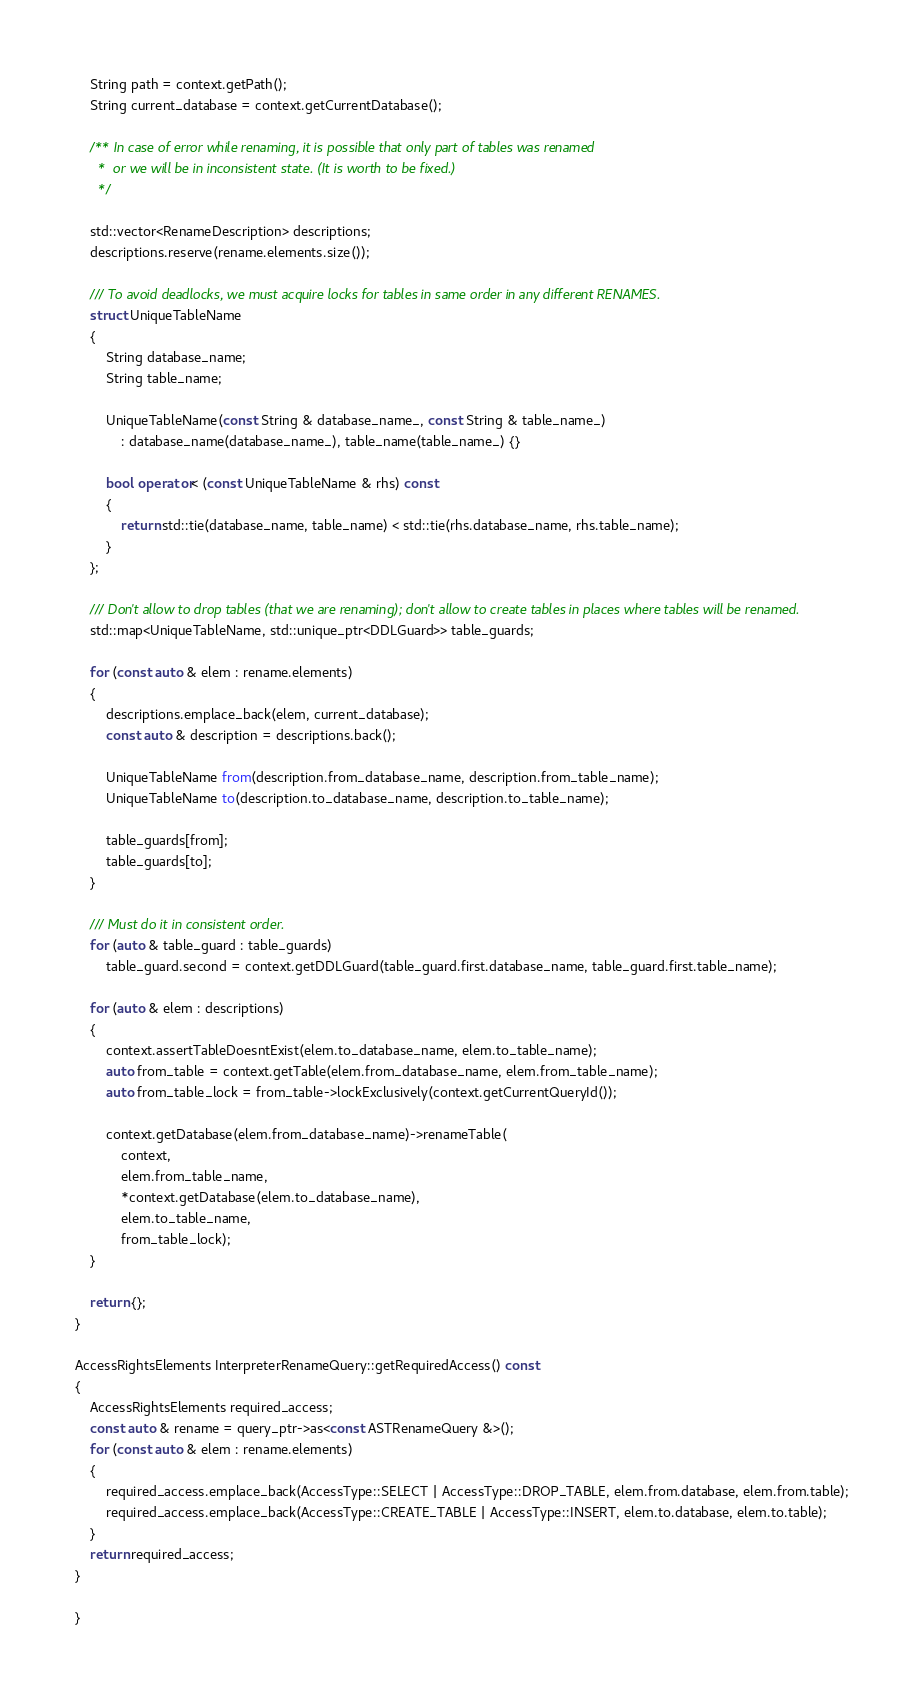Convert code to text. <code><loc_0><loc_0><loc_500><loc_500><_C++_>    String path = context.getPath();
    String current_database = context.getCurrentDatabase();

    /** In case of error while renaming, it is possible that only part of tables was renamed
      *  or we will be in inconsistent state. (It is worth to be fixed.)
      */

    std::vector<RenameDescription> descriptions;
    descriptions.reserve(rename.elements.size());

    /// To avoid deadlocks, we must acquire locks for tables in same order in any different RENAMES.
    struct UniqueTableName
    {
        String database_name;
        String table_name;

        UniqueTableName(const String & database_name_, const String & table_name_)
            : database_name(database_name_), table_name(table_name_) {}

        bool operator< (const UniqueTableName & rhs) const
        {
            return std::tie(database_name, table_name) < std::tie(rhs.database_name, rhs.table_name);
        }
    };

    /// Don't allow to drop tables (that we are renaming); don't allow to create tables in places where tables will be renamed.
    std::map<UniqueTableName, std::unique_ptr<DDLGuard>> table_guards;

    for (const auto & elem : rename.elements)
    {
        descriptions.emplace_back(elem, current_database);
        const auto & description = descriptions.back();

        UniqueTableName from(description.from_database_name, description.from_table_name);
        UniqueTableName to(description.to_database_name, description.to_table_name);

        table_guards[from];
        table_guards[to];
    }

    /// Must do it in consistent order.
    for (auto & table_guard : table_guards)
        table_guard.second = context.getDDLGuard(table_guard.first.database_name, table_guard.first.table_name);

    for (auto & elem : descriptions)
    {
        context.assertTableDoesntExist(elem.to_database_name, elem.to_table_name);
        auto from_table = context.getTable(elem.from_database_name, elem.from_table_name);
        auto from_table_lock = from_table->lockExclusively(context.getCurrentQueryId());

        context.getDatabase(elem.from_database_name)->renameTable(
            context,
            elem.from_table_name,
            *context.getDatabase(elem.to_database_name),
            elem.to_table_name,
            from_table_lock);
    }

    return {};
}

AccessRightsElements InterpreterRenameQuery::getRequiredAccess() const
{
    AccessRightsElements required_access;
    const auto & rename = query_ptr->as<const ASTRenameQuery &>();
    for (const auto & elem : rename.elements)
    {
        required_access.emplace_back(AccessType::SELECT | AccessType::DROP_TABLE, elem.from.database, elem.from.table);
        required_access.emplace_back(AccessType::CREATE_TABLE | AccessType::INSERT, elem.to.database, elem.to.table);
    }
    return required_access;
}

}
</code> 